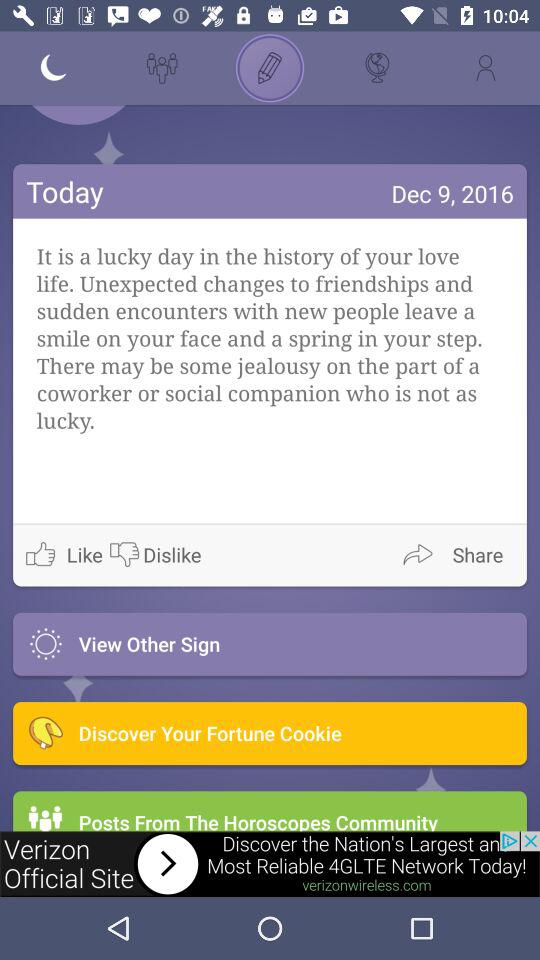In which month was the post posted? The post was posted in the month of December. 